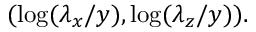<formula> <loc_0><loc_0><loc_500><loc_500>( \log ( \lambda _ { x } / y ) , \log ( \lambda _ { z } / y ) ) .</formula> 